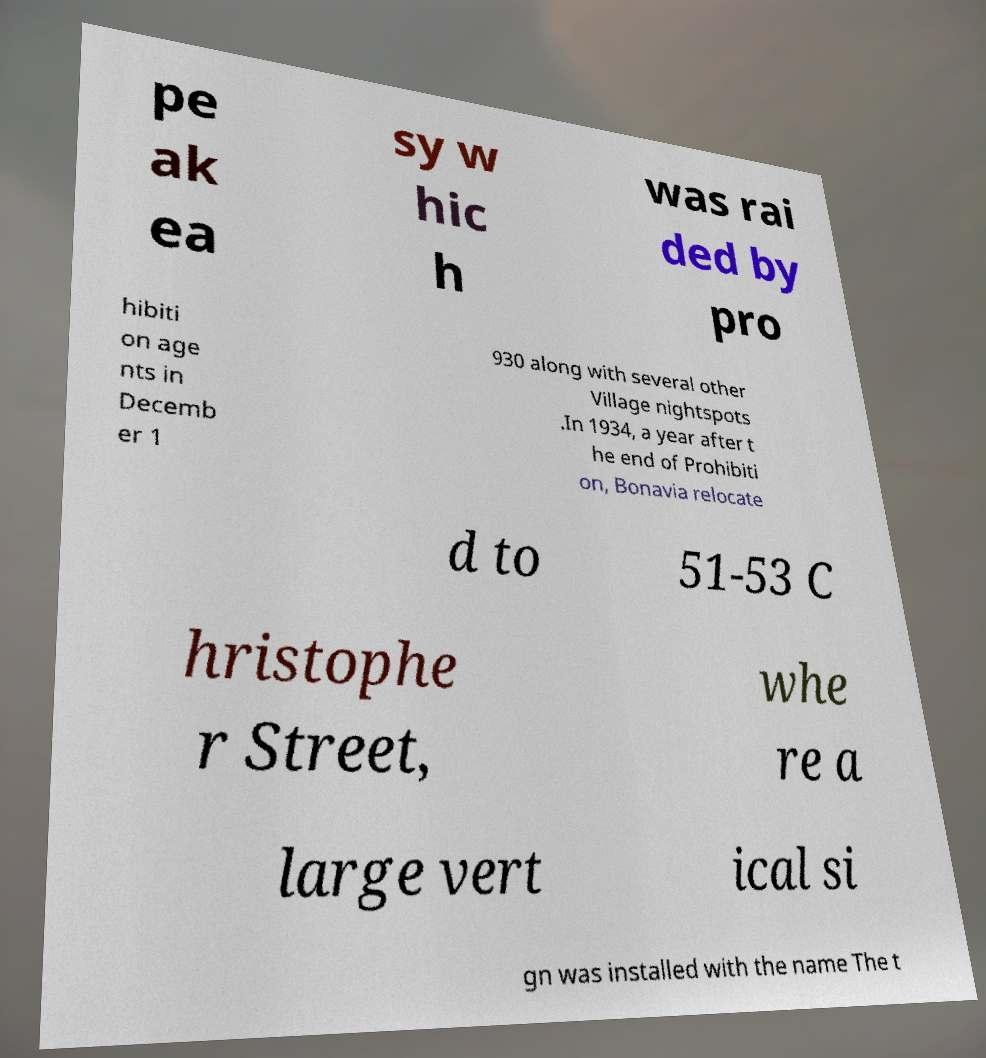What messages or text are displayed in this image? I need them in a readable, typed format. pe ak ea sy w hic h was rai ded by pro hibiti on age nts in Decemb er 1 930 along with several other Village nightspots .In 1934, a year after t he end of Prohibiti on, Bonavia relocate d to 51-53 C hristophe r Street, whe re a large vert ical si gn was installed with the name The t 